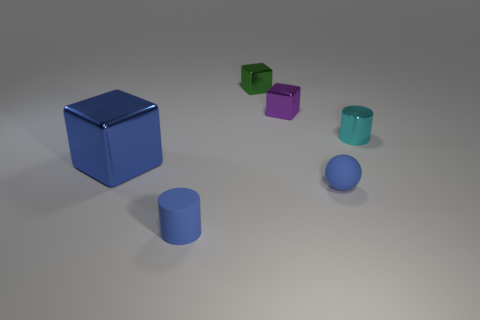Is the color of the large shiny thing the same as the tiny matte thing that is on the right side of the purple metal cube?
Offer a very short reply. Yes. There is a blue object that is the same material as the tiny cyan object; what is its size?
Offer a very short reply. Large. Do the large thing and the tiny blue object behind the small matte cylinder have the same material?
Provide a succinct answer. No. There is another object that is the same shape as the cyan metal thing; what is its material?
Your answer should be compact. Rubber. What number of other things are there of the same shape as the small purple metallic object?
Ensure brevity in your answer.  2. There is a metal object in front of the cyan metal cylinder; what shape is it?
Your answer should be compact. Cube. What color is the metal cylinder?
Keep it short and to the point. Cyan. How many other things are there of the same size as the blue cylinder?
Your answer should be very brief. 4. What material is the tiny blue thing on the right side of the tiny cylinder in front of the large object made of?
Your response must be concise. Rubber. There is a purple metal thing; does it have the same size as the cylinder on the left side of the cyan cylinder?
Provide a succinct answer. Yes. 